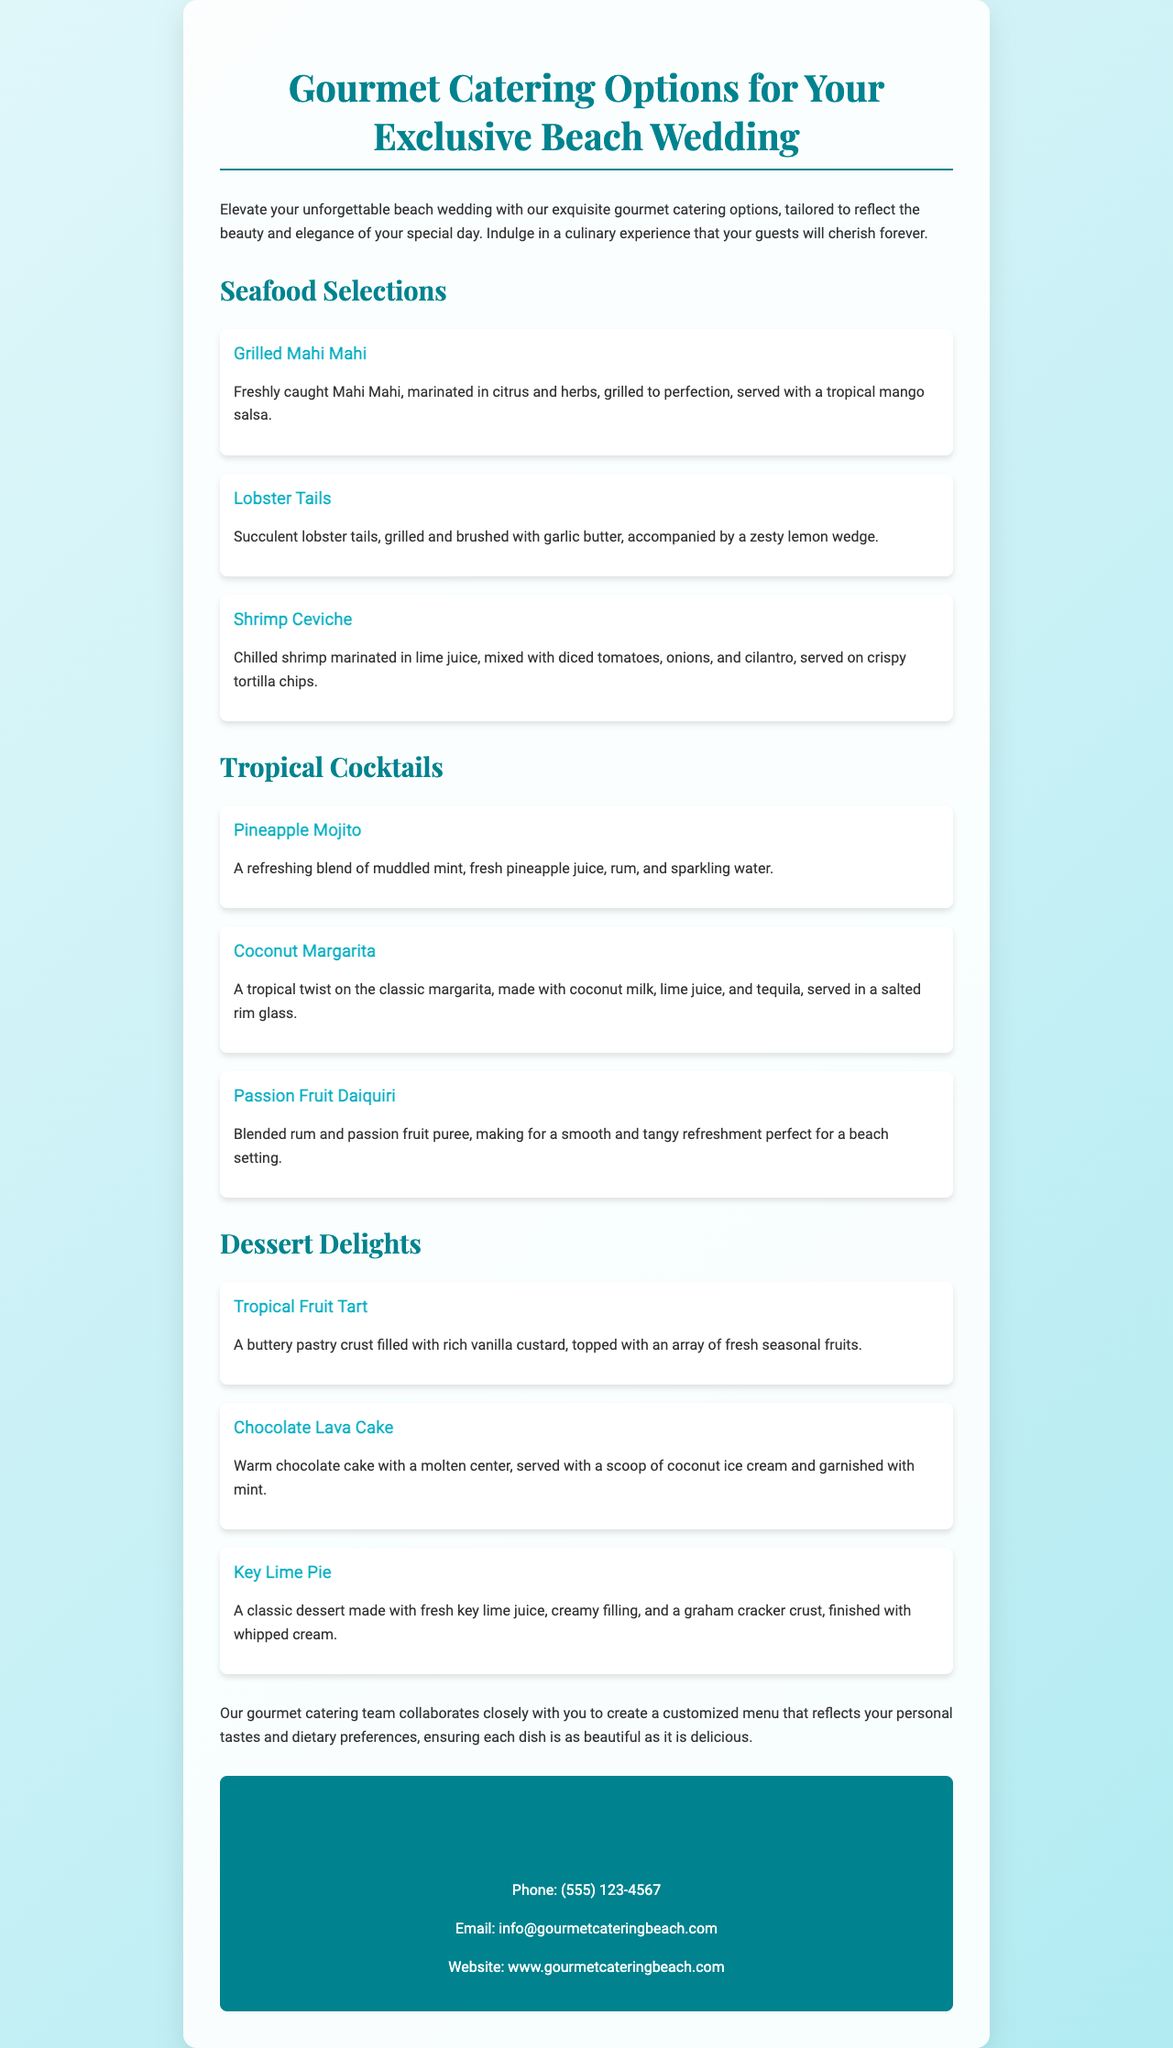What is the title of the brochure? The title is prominently displayed at the top of the document and captures the main theme of the content.
Answer: Gourmet Catering Options for Your Exclusive Beach Wedding How many seafood selections are listed? The document lists three seafood options under the "Seafood Selections" section.
Answer: 3 What cocktail includes fresh pineapple juice? The document specifies that the "Pineapple Mojito" is made with fresh pineapple juice.
Answer: Pineapple Mojito Which dessert has a molten center? The description for the dessert indicates that the "Chocolate Lava Cake" has a molten center.
Answer: Chocolate Lava Cake What is the contact phone number provided? The document includes contact information, specifically the phone number for inquiries.
Answer: (555) 123-4567 What type of style is emphasized in the catering options? The culinary experience described is focused on elegance and beauty to match the wedding setting.
Answer: Exquisite How is the Mahi Mahi prepared? The preparation method for Mahi Mahi is mentioned in the seafood selections section.
Answer: Grilled What is included in the Coconut Margarita? The ingredients listed for this cocktail reveal its unique tropical flavor.
Answer: Coconut milk, lime juice, tequila What is the texture of the Tropical Fruit Tart's crust? The document describes the tart's crust, indicating its essential quality.
Answer: Buttery 